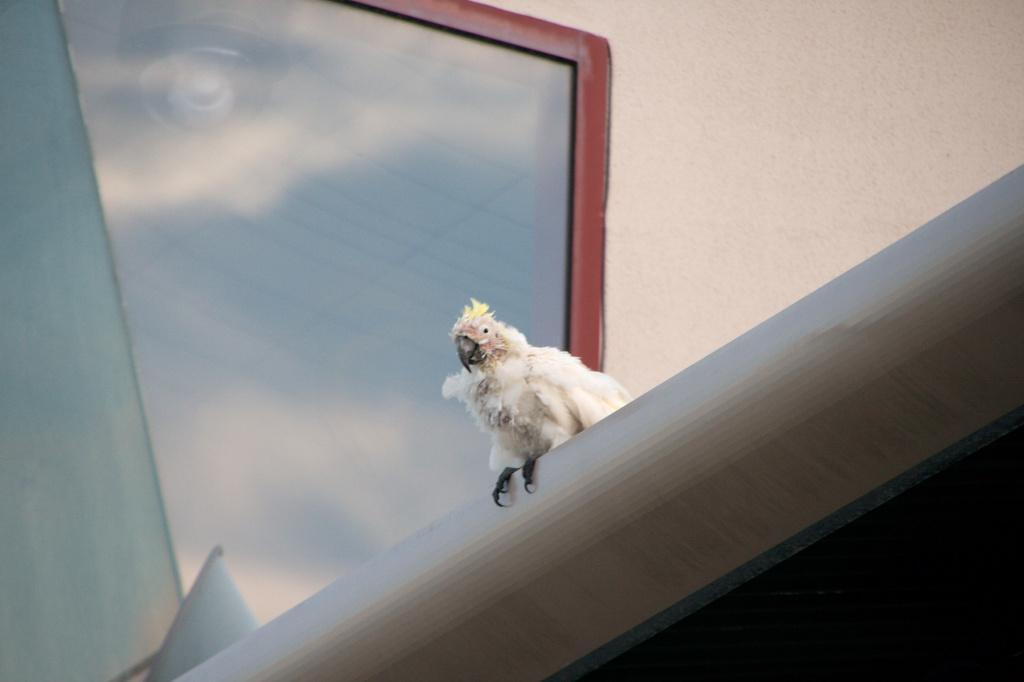Describe this image in one or two sentences. In this image, we can see a bird on the gray surface. Background we can see the wall and glass object. 